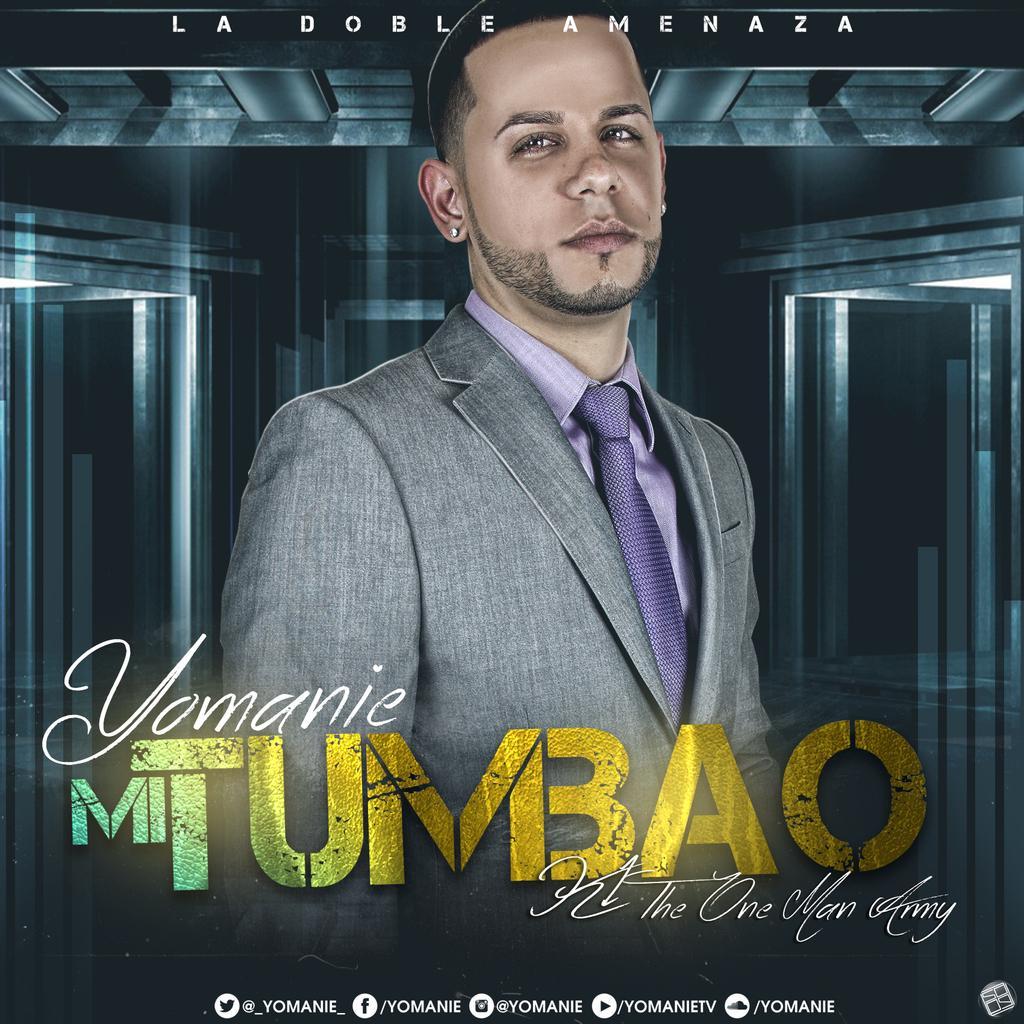Please provide a concise description of this image. In this image we can see a poster in which we can see a person wearing blazer, shirt and purple color tie. Here we can see some edited text. 